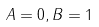<formula> <loc_0><loc_0><loc_500><loc_500>A = 0 , B = 1</formula> 